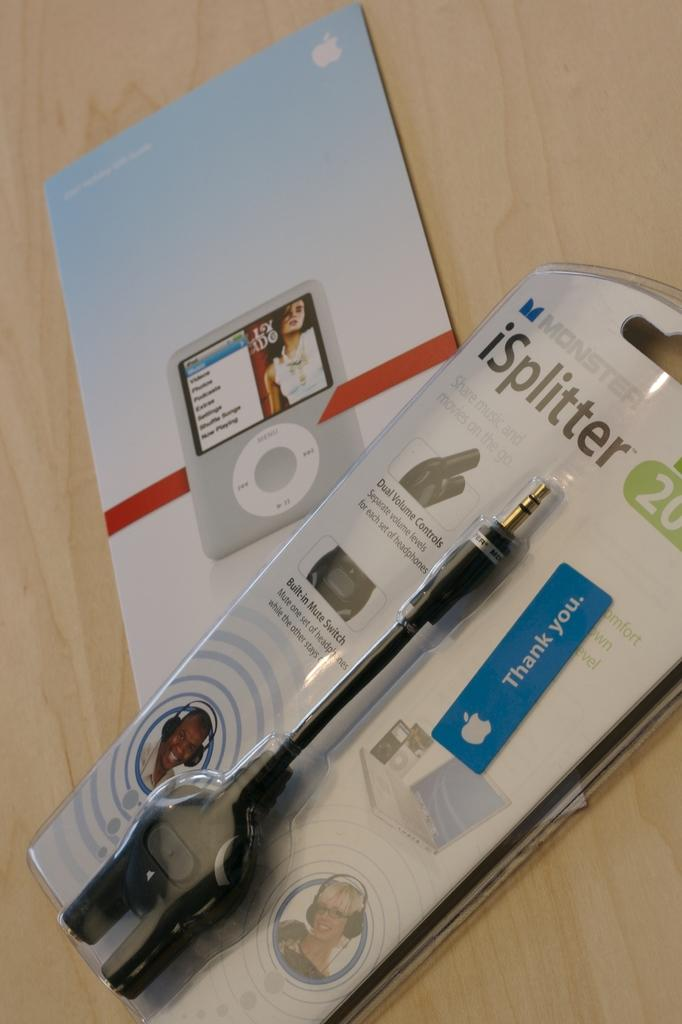What is the primary surface visible in the image? There is a wooden surface in the image. What type of items are placed on the wooden surface? The objects on the wooden surface have photos of people, logos, and text on them. Can you describe the content of the photos on the objects? The photos on the objects are of people. What other features can be seen on the objects? The objects also have logos and text on them. What type of prose can be read on the objects in the image? There is no prose present on the objects in the image; they have photos, logos, and text. How does the image look from a downtown perspective? The image does not depict a downtown perspective; it shows objects on a wooden surface. 